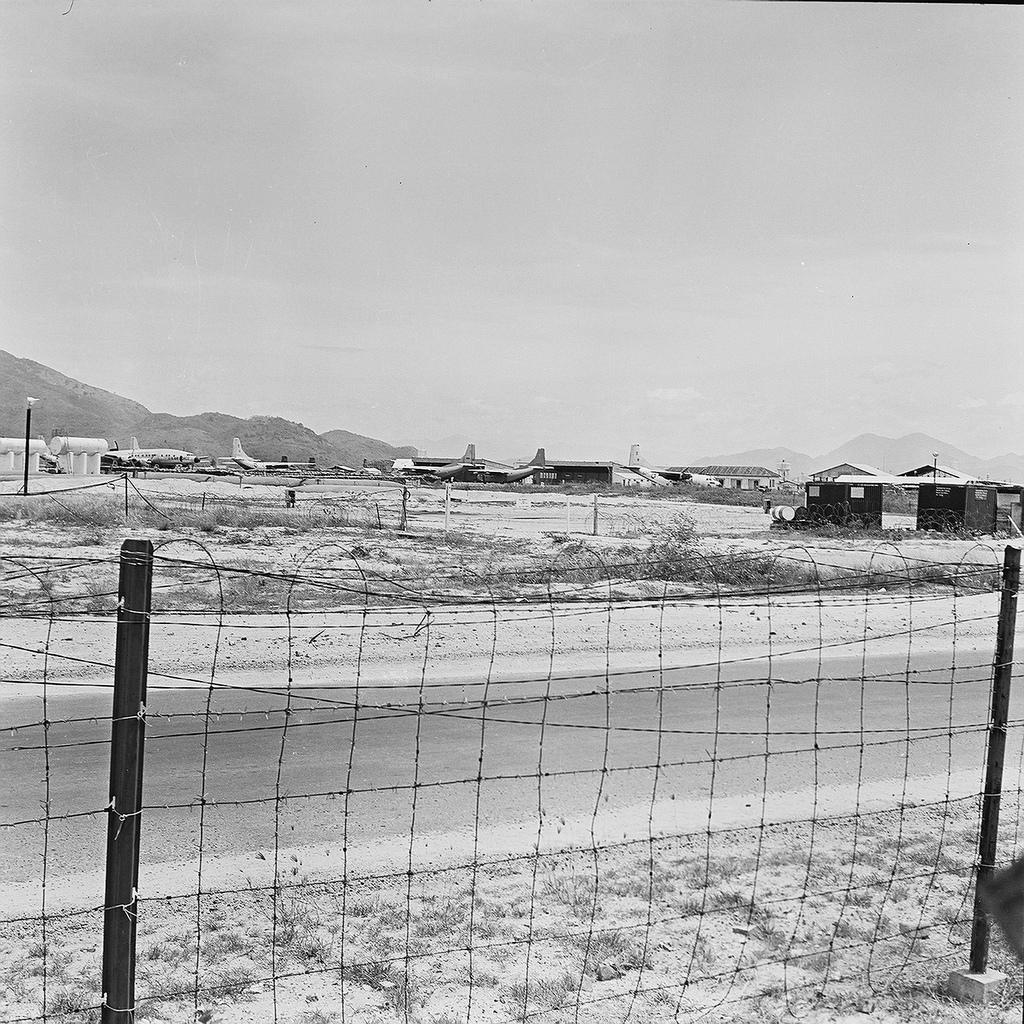Could you give a brief overview of what you see in this image? It looks like a black and white picture, we can see the fence, path, pole and airplanes on the path. Behind the airplanes there is a hill and the sky. 